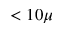<formula> <loc_0><loc_0><loc_500><loc_500>< 1 0 \mu</formula> 